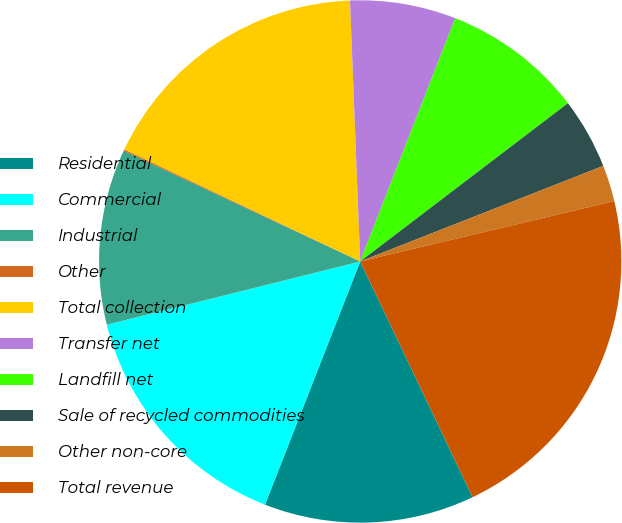<chart> <loc_0><loc_0><loc_500><loc_500><pie_chart><fcel>Residential<fcel>Commercial<fcel>Industrial<fcel>Other<fcel>Total collection<fcel>Transfer net<fcel>Landfill net<fcel>Sale of recycled commodities<fcel>Other non-core<fcel>Total revenue<nl><fcel>13.02%<fcel>15.17%<fcel>10.86%<fcel>0.09%<fcel>17.32%<fcel>6.55%<fcel>8.71%<fcel>4.4%<fcel>2.25%<fcel>21.63%<nl></chart> 